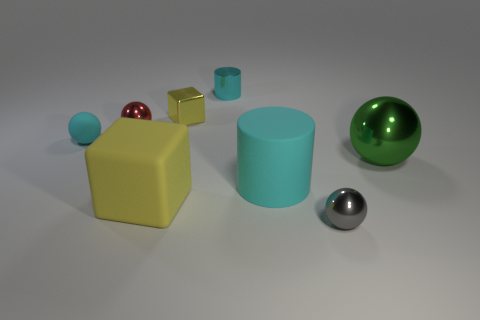Add 2 large cyan objects. How many objects exist? 10 Subtract all cylinders. How many objects are left? 6 Add 5 tiny cylinders. How many tiny cylinders exist? 6 Subtract 0 gray cubes. How many objects are left? 8 Subtract all big shiny spheres. Subtract all large metal blocks. How many objects are left? 7 Add 3 tiny yellow things. How many tiny yellow things are left? 4 